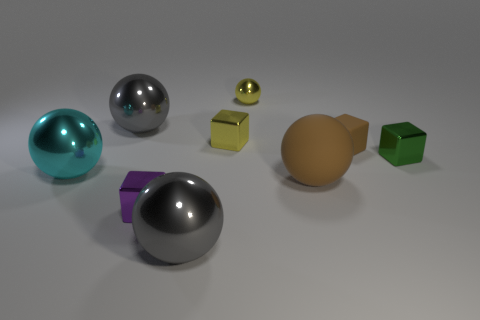Subtract 1 cubes. How many cubes are left? 3 Subtract all brown spheres. How many spheres are left? 4 Subtract all cyan balls. How many balls are left? 4 Add 1 cyan objects. How many objects exist? 10 Subtract all yellow balls. Subtract all brown cylinders. How many balls are left? 4 Subtract all spheres. How many objects are left? 4 Add 3 small green blocks. How many small green blocks are left? 4 Add 1 cylinders. How many cylinders exist? 1 Subtract 2 gray balls. How many objects are left? 7 Subtract all purple matte things. Subtract all large gray shiny things. How many objects are left? 7 